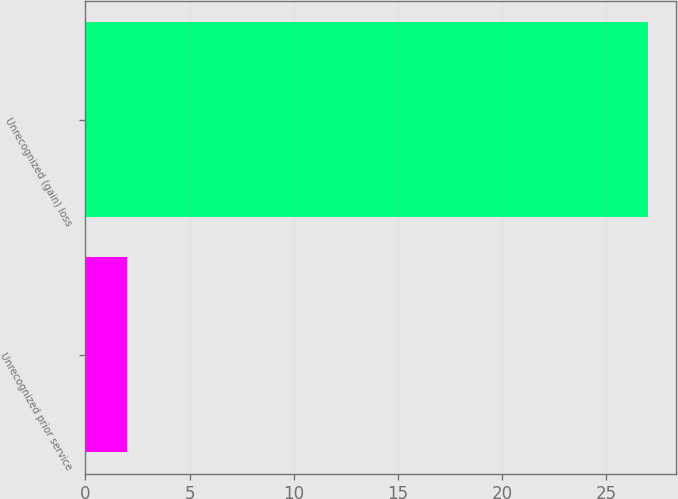<chart> <loc_0><loc_0><loc_500><loc_500><bar_chart><fcel>Unrecognized prior service<fcel>Unrecognized (gain) loss<nl><fcel>2<fcel>27<nl></chart> 